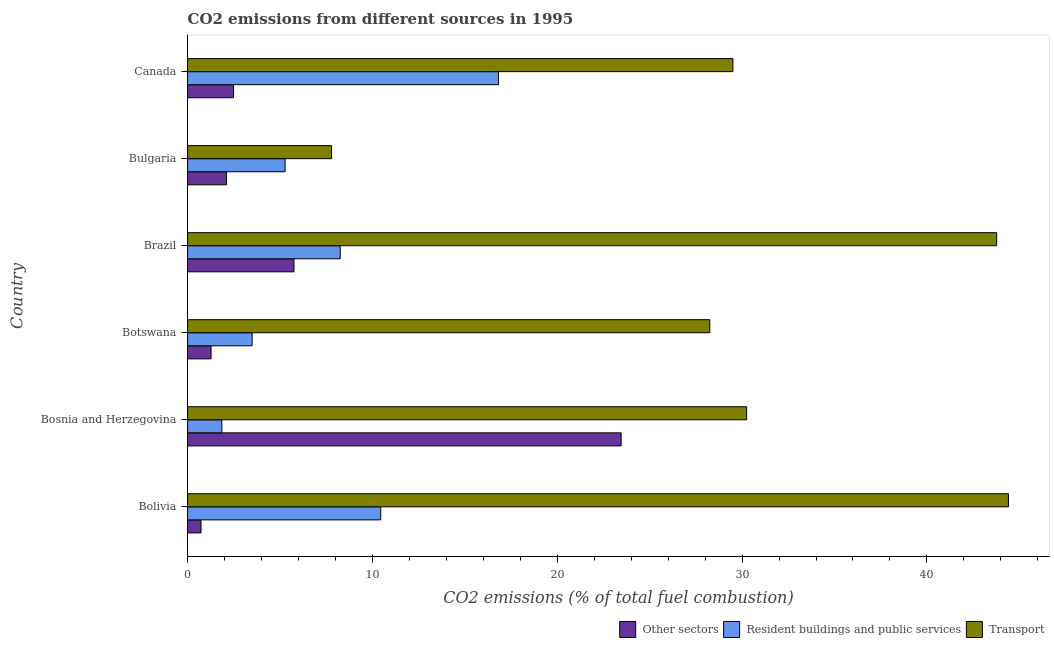How many different coloured bars are there?
Ensure brevity in your answer.  3. Are the number of bars per tick equal to the number of legend labels?
Offer a terse response. Yes. Are the number of bars on each tick of the Y-axis equal?
Make the answer very short. Yes. How many bars are there on the 6th tick from the bottom?
Offer a terse response. 3. What is the label of the 5th group of bars from the top?
Provide a succinct answer. Bosnia and Herzegovina. What is the percentage of co2 emissions from other sectors in Bosnia and Herzegovina?
Provide a short and direct response. 23.46. Across all countries, what is the maximum percentage of co2 emissions from transport?
Your answer should be very brief. 44.41. Across all countries, what is the minimum percentage of co2 emissions from other sectors?
Your response must be concise. 0.73. In which country was the percentage of co2 emissions from other sectors minimum?
Provide a succinct answer. Bolivia. What is the total percentage of co2 emissions from resident buildings and public services in the graph?
Provide a short and direct response. 46.15. What is the difference between the percentage of co2 emissions from transport in Botswana and that in Brazil?
Offer a terse response. -15.52. What is the difference between the percentage of co2 emissions from transport in Brazil and the percentage of co2 emissions from resident buildings and public services in Canada?
Give a very brief answer. 26.95. What is the average percentage of co2 emissions from other sectors per country?
Provide a succinct answer. 5.97. What is the difference between the percentage of co2 emissions from resident buildings and public services and percentage of co2 emissions from transport in Canada?
Your response must be concise. -12.68. What is the ratio of the percentage of co2 emissions from other sectors in Bosnia and Herzegovina to that in Botswana?
Offer a terse response. 18.47. What is the difference between the highest and the second highest percentage of co2 emissions from resident buildings and public services?
Offer a terse response. 6.37. What is the difference between the highest and the lowest percentage of co2 emissions from transport?
Provide a succinct answer. 36.62. Is the sum of the percentage of co2 emissions from resident buildings and public services in Bolivia and Brazil greater than the maximum percentage of co2 emissions from other sectors across all countries?
Provide a short and direct response. No. What does the 1st bar from the top in Botswana represents?
Offer a very short reply. Transport. What does the 1st bar from the bottom in Bolivia represents?
Provide a short and direct response. Other sectors. How many bars are there?
Make the answer very short. 18. Are all the bars in the graph horizontal?
Offer a terse response. Yes. Are the values on the major ticks of X-axis written in scientific E-notation?
Keep it short and to the point. No. Does the graph contain any zero values?
Provide a short and direct response. No. Does the graph contain grids?
Give a very brief answer. No. What is the title of the graph?
Your response must be concise. CO2 emissions from different sources in 1995. What is the label or title of the X-axis?
Your response must be concise. CO2 emissions (% of total fuel combustion). What is the CO2 emissions (% of total fuel combustion) in Other sectors in Bolivia?
Offer a very short reply. 0.73. What is the CO2 emissions (% of total fuel combustion) in Resident buildings and public services in Bolivia?
Offer a terse response. 10.45. What is the CO2 emissions (% of total fuel combustion) of Transport in Bolivia?
Provide a short and direct response. 44.41. What is the CO2 emissions (% of total fuel combustion) of Other sectors in Bosnia and Herzegovina?
Your response must be concise. 23.46. What is the CO2 emissions (% of total fuel combustion) of Resident buildings and public services in Bosnia and Herzegovina?
Your answer should be very brief. 1.85. What is the CO2 emissions (% of total fuel combustion) in Transport in Bosnia and Herzegovina?
Ensure brevity in your answer.  30.25. What is the CO2 emissions (% of total fuel combustion) of Other sectors in Botswana?
Give a very brief answer. 1.27. What is the CO2 emissions (% of total fuel combustion) of Resident buildings and public services in Botswana?
Your answer should be very brief. 3.49. What is the CO2 emissions (% of total fuel combustion) in Transport in Botswana?
Keep it short and to the point. 28.25. What is the CO2 emissions (% of total fuel combustion) in Other sectors in Brazil?
Keep it short and to the point. 5.76. What is the CO2 emissions (% of total fuel combustion) in Resident buildings and public services in Brazil?
Your response must be concise. 8.26. What is the CO2 emissions (% of total fuel combustion) in Transport in Brazil?
Give a very brief answer. 43.77. What is the CO2 emissions (% of total fuel combustion) of Other sectors in Bulgaria?
Provide a short and direct response. 2.1. What is the CO2 emissions (% of total fuel combustion) in Resident buildings and public services in Bulgaria?
Provide a succinct answer. 5.28. What is the CO2 emissions (% of total fuel combustion) in Transport in Bulgaria?
Your answer should be very brief. 7.79. What is the CO2 emissions (% of total fuel combustion) in Other sectors in Canada?
Your answer should be compact. 2.49. What is the CO2 emissions (% of total fuel combustion) of Resident buildings and public services in Canada?
Your answer should be very brief. 16.82. What is the CO2 emissions (% of total fuel combustion) of Transport in Canada?
Offer a very short reply. 29.5. Across all countries, what is the maximum CO2 emissions (% of total fuel combustion) in Other sectors?
Give a very brief answer. 23.46. Across all countries, what is the maximum CO2 emissions (% of total fuel combustion) in Resident buildings and public services?
Keep it short and to the point. 16.82. Across all countries, what is the maximum CO2 emissions (% of total fuel combustion) in Transport?
Offer a very short reply. 44.41. Across all countries, what is the minimum CO2 emissions (% of total fuel combustion) of Other sectors?
Your response must be concise. 0.73. Across all countries, what is the minimum CO2 emissions (% of total fuel combustion) in Resident buildings and public services?
Provide a succinct answer. 1.85. Across all countries, what is the minimum CO2 emissions (% of total fuel combustion) of Transport?
Provide a succinct answer. 7.79. What is the total CO2 emissions (% of total fuel combustion) of Other sectors in the graph?
Your answer should be very brief. 35.8. What is the total CO2 emissions (% of total fuel combustion) in Resident buildings and public services in the graph?
Provide a short and direct response. 46.15. What is the total CO2 emissions (% of total fuel combustion) of Transport in the graph?
Make the answer very short. 183.98. What is the difference between the CO2 emissions (% of total fuel combustion) of Other sectors in Bolivia and that in Bosnia and Herzegovina?
Your response must be concise. -22.73. What is the difference between the CO2 emissions (% of total fuel combustion) in Resident buildings and public services in Bolivia and that in Bosnia and Herzegovina?
Your response must be concise. 8.6. What is the difference between the CO2 emissions (% of total fuel combustion) of Transport in Bolivia and that in Bosnia and Herzegovina?
Offer a very short reply. 14.17. What is the difference between the CO2 emissions (% of total fuel combustion) in Other sectors in Bolivia and that in Botswana?
Give a very brief answer. -0.54. What is the difference between the CO2 emissions (% of total fuel combustion) in Resident buildings and public services in Bolivia and that in Botswana?
Ensure brevity in your answer.  6.96. What is the difference between the CO2 emissions (% of total fuel combustion) in Transport in Bolivia and that in Botswana?
Provide a short and direct response. 16.16. What is the difference between the CO2 emissions (% of total fuel combustion) in Other sectors in Bolivia and that in Brazil?
Your response must be concise. -5.03. What is the difference between the CO2 emissions (% of total fuel combustion) of Resident buildings and public services in Bolivia and that in Brazil?
Offer a very short reply. 2.19. What is the difference between the CO2 emissions (% of total fuel combustion) in Transport in Bolivia and that in Brazil?
Provide a short and direct response. 0.64. What is the difference between the CO2 emissions (% of total fuel combustion) of Other sectors in Bolivia and that in Bulgaria?
Your answer should be compact. -1.38. What is the difference between the CO2 emissions (% of total fuel combustion) in Resident buildings and public services in Bolivia and that in Bulgaria?
Your answer should be compact. 5.17. What is the difference between the CO2 emissions (% of total fuel combustion) in Transport in Bolivia and that in Bulgaria?
Your response must be concise. 36.62. What is the difference between the CO2 emissions (% of total fuel combustion) in Other sectors in Bolivia and that in Canada?
Your response must be concise. -1.76. What is the difference between the CO2 emissions (% of total fuel combustion) in Resident buildings and public services in Bolivia and that in Canada?
Ensure brevity in your answer.  -6.37. What is the difference between the CO2 emissions (% of total fuel combustion) in Transport in Bolivia and that in Canada?
Your answer should be compact. 14.91. What is the difference between the CO2 emissions (% of total fuel combustion) in Other sectors in Bosnia and Herzegovina and that in Botswana?
Your answer should be very brief. 22.19. What is the difference between the CO2 emissions (% of total fuel combustion) in Resident buildings and public services in Bosnia and Herzegovina and that in Botswana?
Make the answer very short. -1.64. What is the difference between the CO2 emissions (% of total fuel combustion) of Transport in Bosnia and Herzegovina and that in Botswana?
Your answer should be very brief. 1.99. What is the difference between the CO2 emissions (% of total fuel combustion) in Other sectors in Bosnia and Herzegovina and that in Brazil?
Offer a terse response. 17.7. What is the difference between the CO2 emissions (% of total fuel combustion) of Resident buildings and public services in Bosnia and Herzegovina and that in Brazil?
Offer a terse response. -6.4. What is the difference between the CO2 emissions (% of total fuel combustion) in Transport in Bosnia and Herzegovina and that in Brazil?
Ensure brevity in your answer.  -13.53. What is the difference between the CO2 emissions (% of total fuel combustion) of Other sectors in Bosnia and Herzegovina and that in Bulgaria?
Your answer should be compact. 21.35. What is the difference between the CO2 emissions (% of total fuel combustion) of Resident buildings and public services in Bosnia and Herzegovina and that in Bulgaria?
Provide a short and direct response. -3.42. What is the difference between the CO2 emissions (% of total fuel combustion) in Transport in Bosnia and Herzegovina and that in Bulgaria?
Ensure brevity in your answer.  22.46. What is the difference between the CO2 emissions (% of total fuel combustion) of Other sectors in Bosnia and Herzegovina and that in Canada?
Provide a short and direct response. 20.97. What is the difference between the CO2 emissions (% of total fuel combustion) in Resident buildings and public services in Bosnia and Herzegovina and that in Canada?
Make the answer very short. -14.97. What is the difference between the CO2 emissions (% of total fuel combustion) in Transport in Bosnia and Herzegovina and that in Canada?
Make the answer very short. 0.74. What is the difference between the CO2 emissions (% of total fuel combustion) of Other sectors in Botswana and that in Brazil?
Keep it short and to the point. -4.49. What is the difference between the CO2 emissions (% of total fuel combustion) of Resident buildings and public services in Botswana and that in Brazil?
Offer a terse response. -4.76. What is the difference between the CO2 emissions (% of total fuel combustion) in Transport in Botswana and that in Brazil?
Offer a very short reply. -15.52. What is the difference between the CO2 emissions (% of total fuel combustion) in Other sectors in Botswana and that in Bulgaria?
Your answer should be very brief. -0.83. What is the difference between the CO2 emissions (% of total fuel combustion) in Resident buildings and public services in Botswana and that in Bulgaria?
Provide a succinct answer. -1.78. What is the difference between the CO2 emissions (% of total fuel combustion) in Transport in Botswana and that in Bulgaria?
Provide a succinct answer. 20.46. What is the difference between the CO2 emissions (% of total fuel combustion) in Other sectors in Botswana and that in Canada?
Give a very brief answer. -1.22. What is the difference between the CO2 emissions (% of total fuel combustion) of Resident buildings and public services in Botswana and that in Canada?
Provide a short and direct response. -13.33. What is the difference between the CO2 emissions (% of total fuel combustion) of Transport in Botswana and that in Canada?
Your answer should be compact. -1.25. What is the difference between the CO2 emissions (% of total fuel combustion) of Other sectors in Brazil and that in Bulgaria?
Provide a short and direct response. 3.65. What is the difference between the CO2 emissions (% of total fuel combustion) of Resident buildings and public services in Brazil and that in Bulgaria?
Provide a short and direct response. 2.98. What is the difference between the CO2 emissions (% of total fuel combustion) of Transport in Brazil and that in Bulgaria?
Ensure brevity in your answer.  35.98. What is the difference between the CO2 emissions (% of total fuel combustion) of Other sectors in Brazil and that in Canada?
Your answer should be compact. 3.27. What is the difference between the CO2 emissions (% of total fuel combustion) of Resident buildings and public services in Brazil and that in Canada?
Provide a succinct answer. -8.57. What is the difference between the CO2 emissions (% of total fuel combustion) of Transport in Brazil and that in Canada?
Your answer should be very brief. 14.27. What is the difference between the CO2 emissions (% of total fuel combustion) of Other sectors in Bulgaria and that in Canada?
Keep it short and to the point. -0.38. What is the difference between the CO2 emissions (% of total fuel combustion) in Resident buildings and public services in Bulgaria and that in Canada?
Offer a terse response. -11.55. What is the difference between the CO2 emissions (% of total fuel combustion) of Transport in Bulgaria and that in Canada?
Your answer should be very brief. -21.71. What is the difference between the CO2 emissions (% of total fuel combustion) of Other sectors in Bolivia and the CO2 emissions (% of total fuel combustion) of Resident buildings and public services in Bosnia and Herzegovina?
Ensure brevity in your answer.  -1.13. What is the difference between the CO2 emissions (% of total fuel combustion) in Other sectors in Bolivia and the CO2 emissions (% of total fuel combustion) in Transport in Bosnia and Herzegovina?
Provide a succinct answer. -29.52. What is the difference between the CO2 emissions (% of total fuel combustion) of Resident buildings and public services in Bolivia and the CO2 emissions (% of total fuel combustion) of Transport in Bosnia and Herzegovina?
Offer a very short reply. -19.8. What is the difference between the CO2 emissions (% of total fuel combustion) in Other sectors in Bolivia and the CO2 emissions (% of total fuel combustion) in Resident buildings and public services in Botswana?
Offer a terse response. -2.77. What is the difference between the CO2 emissions (% of total fuel combustion) of Other sectors in Bolivia and the CO2 emissions (% of total fuel combustion) of Transport in Botswana?
Give a very brief answer. -27.53. What is the difference between the CO2 emissions (% of total fuel combustion) in Resident buildings and public services in Bolivia and the CO2 emissions (% of total fuel combustion) in Transport in Botswana?
Offer a very short reply. -17.8. What is the difference between the CO2 emissions (% of total fuel combustion) in Other sectors in Bolivia and the CO2 emissions (% of total fuel combustion) in Resident buildings and public services in Brazil?
Ensure brevity in your answer.  -7.53. What is the difference between the CO2 emissions (% of total fuel combustion) of Other sectors in Bolivia and the CO2 emissions (% of total fuel combustion) of Transport in Brazil?
Provide a succinct answer. -43.05. What is the difference between the CO2 emissions (% of total fuel combustion) in Resident buildings and public services in Bolivia and the CO2 emissions (% of total fuel combustion) in Transport in Brazil?
Offer a very short reply. -33.32. What is the difference between the CO2 emissions (% of total fuel combustion) of Other sectors in Bolivia and the CO2 emissions (% of total fuel combustion) of Resident buildings and public services in Bulgaria?
Offer a terse response. -4.55. What is the difference between the CO2 emissions (% of total fuel combustion) of Other sectors in Bolivia and the CO2 emissions (% of total fuel combustion) of Transport in Bulgaria?
Provide a short and direct response. -7.06. What is the difference between the CO2 emissions (% of total fuel combustion) of Resident buildings and public services in Bolivia and the CO2 emissions (% of total fuel combustion) of Transport in Bulgaria?
Provide a short and direct response. 2.66. What is the difference between the CO2 emissions (% of total fuel combustion) in Other sectors in Bolivia and the CO2 emissions (% of total fuel combustion) in Resident buildings and public services in Canada?
Offer a terse response. -16.1. What is the difference between the CO2 emissions (% of total fuel combustion) of Other sectors in Bolivia and the CO2 emissions (% of total fuel combustion) of Transport in Canada?
Provide a succinct answer. -28.78. What is the difference between the CO2 emissions (% of total fuel combustion) of Resident buildings and public services in Bolivia and the CO2 emissions (% of total fuel combustion) of Transport in Canada?
Keep it short and to the point. -19.05. What is the difference between the CO2 emissions (% of total fuel combustion) in Other sectors in Bosnia and Herzegovina and the CO2 emissions (% of total fuel combustion) in Resident buildings and public services in Botswana?
Your answer should be compact. 19.96. What is the difference between the CO2 emissions (% of total fuel combustion) in Other sectors in Bosnia and Herzegovina and the CO2 emissions (% of total fuel combustion) in Transport in Botswana?
Provide a succinct answer. -4.8. What is the difference between the CO2 emissions (% of total fuel combustion) of Resident buildings and public services in Bosnia and Herzegovina and the CO2 emissions (% of total fuel combustion) of Transport in Botswana?
Offer a very short reply. -26.4. What is the difference between the CO2 emissions (% of total fuel combustion) of Other sectors in Bosnia and Herzegovina and the CO2 emissions (% of total fuel combustion) of Resident buildings and public services in Brazil?
Offer a terse response. 15.2. What is the difference between the CO2 emissions (% of total fuel combustion) in Other sectors in Bosnia and Herzegovina and the CO2 emissions (% of total fuel combustion) in Transport in Brazil?
Keep it short and to the point. -20.32. What is the difference between the CO2 emissions (% of total fuel combustion) of Resident buildings and public services in Bosnia and Herzegovina and the CO2 emissions (% of total fuel combustion) of Transport in Brazil?
Your response must be concise. -41.92. What is the difference between the CO2 emissions (% of total fuel combustion) in Other sectors in Bosnia and Herzegovina and the CO2 emissions (% of total fuel combustion) in Resident buildings and public services in Bulgaria?
Ensure brevity in your answer.  18.18. What is the difference between the CO2 emissions (% of total fuel combustion) of Other sectors in Bosnia and Herzegovina and the CO2 emissions (% of total fuel combustion) of Transport in Bulgaria?
Ensure brevity in your answer.  15.67. What is the difference between the CO2 emissions (% of total fuel combustion) of Resident buildings and public services in Bosnia and Herzegovina and the CO2 emissions (% of total fuel combustion) of Transport in Bulgaria?
Ensure brevity in your answer.  -5.94. What is the difference between the CO2 emissions (% of total fuel combustion) of Other sectors in Bosnia and Herzegovina and the CO2 emissions (% of total fuel combustion) of Resident buildings and public services in Canada?
Your response must be concise. 6.63. What is the difference between the CO2 emissions (% of total fuel combustion) of Other sectors in Bosnia and Herzegovina and the CO2 emissions (% of total fuel combustion) of Transport in Canada?
Give a very brief answer. -6.05. What is the difference between the CO2 emissions (% of total fuel combustion) of Resident buildings and public services in Bosnia and Herzegovina and the CO2 emissions (% of total fuel combustion) of Transport in Canada?
Offer a terse response. -27.65. What is the difference between the CO2 emissions (% of total fuel combustion) in Other sectors in Botswana and the CO2 emissions (% of total fuel combustion) in Resident buildings and public services in Brazil?
Provide a succinct answer. -6.99. What is the difference between the CO2 emissions (% of total fuel combustion) in Other sectors in Botswana and the CO2 emissions (% of total fuel combustion) in Transport in Brazil?
Provide a succinct answer. -42.5. What is the difference between the CO2 emissions (% of total fuel combustion) in Resident buildings and public services in Botswana and the CO2 emissions (% of total fuel combustion) in Transport in Brazil?
Give a very brief answer. -40.28. What is the difference between the CO2 emissions (% of total fuel combustion) in Other sectors in Botswana and the CO2 emissions (% of total fuel combustion) in Resident buildings and public services in Bulgaria?
Keep it short and to the point. -4.01. What is the difference between the CO2 emissions (% of total fuel combustion) in Other sectors in Botswana and the CO2 emissions (% of total fuel combustion) in Transport in Bulgaria?
Make the answer very short. -6.52. What is the difference between the CO2 emissions (% of total fuel combustion) in Resident buildings and public services in Botswana and the CO2 emissions (% of total fuel combustion) in Transport in Bulgaria?
Ensure brevity in your answer.  -4.3. What is the difference between the CO2 emissions (% of total fuel combustion) in Other sectors in Botswana and the CO2 emissions (% of total fuel combustion) in Resident buildings and public services in Canada?
Offer a terse response. -15.55. What is the difference between the CO2 emissions (% of total fuel combustion) in Other sectors in Botswana and the CO2 emissions (% of total fuel combustion) in Transport in Canada?
Provide a succinct answer. -28.23. What is the difference between the CO2 emissions (% of total fuel combustion) of Resident buildings and public services in Botswana and the CO2 emissions (% of total fuel combustion) of Transport in Canada?
Your answer should be compact. -26.01. What is the difference between the CO2 emissions (% of total fuel combustion) in Other sectors in Brazil and the CO2 emissions (% of total fuel combustion) in Resident buildings and public services in Bulgaria?
Your answer should be very brief. 0.48. What is the difference between the CO2 emissions (% of total fuel combustion) in Other sectors in Brazil and the CO2 emissions (% of total fuel combustion) in Transport in Bulgaria?
Ensure brevity in your answer.  -2.03. What is the difference between the CO2 emissions (% of total fuel combustion) of Resident buildings and public services in Brazil and the CO2 emissions (% of total fuel combustion) of Transport in Bulgaria?
Your answer should be compact. 0.47. What is the difference between the CO2 emissions (% of total fuel combustion) of Other sectors in Brazil and the CO2 emissions (% of total fuel combustion) of Resident buildings and public services in Canada?
Make the answer very short. -11.07. What is the difference between the CO2 emissions (% of total fuel combustion) in Other sectors in Brazil and the CO2 emissions (% of total fuel combustion) in Transport in Canada?
Your response must be concise. -23.75. What is the difference between the CO2 emissions (% of total fuel combustion) of Resident buildings and public services in Brazil and the CO2 emissions (% of total fuel combustion) of Transport in Canada?
Provide a short and direct response. -21.25. What is the difference between the CO2 emissions (% of total fuel combustion) of Other sectors in Bulgaria and the CO2 emissions (% of total fuel combustion) of Resident buildings and public services in Canada?
Your response must be concise. -14.72. What is the difference between the CO2 emissions (% of total fuel combustion) of Other sectors in Bulgaria and the CO2 emissions (% of total fuel combustion) of Transport in Canada?
Ensure brevity in your answer.  -27.4. What is the difference between the CO2 emissions (% of total fuel combustion) of Resident buildings and public services in Bulgaria and the CO2 emissions (% of total fuel combustion) of Transport in Canada?
Offer a very short reply. -24.23. What is the average CO2 emissions (% of total fuel combustion) in Other sectors per country?
Give a very brief answer. 5.97. What is the average CO2 emissions (% of total fuel combustion) in Resident buildings and public services per country?
Offer a very short reply. 7.69. What is the average CO2 emissions (% of total fuel combustion) in Transport per country?
Offer a very short reply. 30.66. What is the difference between the CO2 emissions (% of total fuel combustion) in Other sectors and CO2 emissions (% of total fuel combustion) in Resident buildings and public services in Bolivia?
Ensure brevity in your answer.  -9.72. What is the difference between the CO2 emissions (% of total fuel combustion) in Other sectors and CO2 emissions (% of total fuel combustion) in Transport in Bolivia?
Offer a very short reply. -43.69. What is the difference between the CO2 emissions (% of total fuel combustion) of Resident buildings and public services and CO2 emissions (% of total fuel combustion) of Transport in Bolivia?
Your answer should be very brief. -33.96. What is the difference between the CO2 emissions (% of total fuel combustion) of Other sectors and CO2 emissions (% of total fuel combustion) of Resident buildings and public services in Bosnia and Herzegovina?
Make the answer very short. 21.6. What is the difference between the CO2 emissions (% of total fuel combustion) of Other sectors and CO2 emissions (% of total fuel combustion) of Transport in Bosnia and Herzegovina?
Offer a very short reply. -6.79. What is the difference between the CO2 emissions (% of total fuel combustion) in Resident buildings and public services and CO2 emissions (% of total fuel combustion) in Transport in Bosnia and Herzegovina?
Your answer should be compact. -28.4. What is the difference between the CO2 emissions (% of total fuel combustion) of Other sectors and CO2 emissions (% of total fuel combustion) of Resident buildings and public services in Botswana?
Give a very brief answer. -2.22. What is the difference between the CO2 emissions (% of total fuel combustion) in Other sectors and CO2 emissions (% of total fuel combustion) in Transport in Botswana?
Your answer should be very brief. -26.98. What is the difference between the CO2 emissions (% of total fuel combustion) of Resident buildings and public services and CO2 emissions (% of total fuel combustion) of Transport in Botswana?
Give a very brief answer. -24.76. What is the difference between the CO2 emissions (% of total fuel combustion) of Other sectors and CO2 emissions (% of total fuel combustion) of Resident buildings and public services in Brazil?
Give a very brief answer. -2.5. What is the difference between the CO2 emissions (% of total fuel combustion) in Other sectors and CO2 emissions (% of total fuel combustion) in Transport in Brazil?
Ensure brevity in your answer.  -38.02. What is the difference between the CO2 emissions (% of total fuel combustion) of Resident buildings and public services and CO2 emissions (% of total fuel combustion) of Transport in Brazil?
Give a very brief answer. -35.52. What is the difference between the CO2 emissions (% of total fuel combustion) in Other sectors and CO2 emissions (% of total fuel combustion) in Resident buildings and public services in Bulgaria?
Your response must be concise. -3.17. What is the difference between the CO2 emissions (% of total fuel combustion) of Other sectors and CO2 emissions (% of total fuel combustion) of Transport in Bulgaria?
Make the answer very short. -5.69. What is the difference between the CO2 emissions (% of total fuel combustion) of Resident buildings and public services and CO2 emissions (% of total fuel combustion) of Transport in Bulgaria?
Provide a short and direct response. -2.52. What is the difference between the CO2 emissions (% of total fuel combustion) of Other sectors and CO2 emissions (% of total fuel combustion) of Resident buildings and public services in Canada?
Your answer should be compact. -14.34. What is the difference between the CO2 emissions (% of total fuel combustion) in Other sectors and CO2 emissions (% of total fuel combustion) in Transport in Canada?
Offer a terse response. -27.02. What is the difference between the CO2 emissions (% of total fuel combustion) of Resident buildings and public services and CO2 emissions (% of total fuel combustion) of Transport in Canada?
Provide a short and direct response. -12.68. What is the ratio of the CO2 emissions (% of total fuel combustion) in Other sectors in Bolivia to that in Bosnia and Herzegovina?
Ensure brevity in your answer.  0.03. What is the ratio of the CO2 emissions (% of total fuel combustion) in Resident buildings and public services in Bolivia to that in Bosnia and Herzegovina?
Your answer should be very brief. 5.64. What is the ratio of the CO2 emissions (% of total fuel combustion) of Transport in Bolivia to that in Bosnia and Herzegovina?
Ensure brevity in your answer.  1.47. What is the ratio of the CO2 emissions (% of total fuel combustion) of Other sectors in Bolivia to that in Botswana?
Keep it short and to the point. 0.57. What is the ratio of the CO2 emissions (% of total fuel combustion) of Resident buildings and public services in Bolivia to that in Botswana?
Your answer should be very brief. 2.99. What is the ratio of the CO2 emissions (% of total fuel combustion) of Transport in Bolivia to that in Botswana?
Your answer should be compact. 1.57. What is the ratio of the CO2 emissions (% of total fuel combustion) in Other sectors in Bolivia to that in Brazil?
Your response must be concise. 0.13. What is the ratio of the CO2 emissions (% of total fuel combustion) in Resident buildings and public services in Bolivia to that in Brazil?
Give a very brief answer. 1.27. What is the ratio of the CO2 emissions (% of total fuel combustion) of Transport in Bolivia to that in Brazil?
Make the answer very short. 1.01. What is the ratio of the CO2 emissions (% of total fuel combustion) in Other sectors in Bolivia to that in Bulgaria?
Provide a succinct answer. 0.35. What is the ratio of the CO2 emissions (% of total fuel combustion) in Resident buildings and public services in Bolivia to that in Bulgaria?
Ensure brevity in your answer.  1.98. What is the ratio of the CO2 emissions (% of total fuel combustion) in Transport in Bolivia to that in Bulgaria?
Keep it short and to the point. 5.7. What is the ratio of the CO2 emissions (% of total fuel combustion) of Other sectors in Bolivia to that in Canada?
Keep it short and to the point. 0.29. What is the ratio of the CO2 emissions (% of total fuel combustion) of Resident buildings and public services in Bolivia to that in Canada?
Your answer should be compact. 0.62. What is the ratio of the CO2 emissions (% of total fuel combustion) of Transport in Bolivia to that in Canada?
Give a very brief answer. 1.51. What is the ratio of the CO2 emissions (% of total fuel combustion) in Other sectors in Bosnia and Herzegovina to that in Botswana?
Provide a succinct answer. 18.47. What is the ratio of the CO2 emissions (% of total fuel combustion) in Resident buildings and public services in Bosnia and Herzegovina to that in Botswana?
Make the answer very short. 0.53. What is the ratio of the CO2 emissions (% of total fuel combustion) of Transport in Bosnia and Herzegovina to that in Botswana?
Your response must be concise. 1.07. What is the ratio of the CO2 emissions (% of total fuel combustion) of Other sectors in Bosnia and Herzegovina to that in Brazil?
Provide a short and direct response. 4.08. What is the ratio of the CO2 emissions (% of total fuel combustion) in Resident buildings and public services in Bosnia and Herzegovina to that in Brazil?
Give a very brief answer. 0.22. What is the ratio of the CO2 emissions (% of total fuel combustion) in Transport in Bosnia and Herzegovina to that in Brazil?
Provide a short and direct response. 0.69. What is the ratio of the CO2 emissions (% of total fuel combustion) in Other sectors in Bosnia and Herzegovina to that in Bulgaria?
Your answer should be very brief. 11.16. What is the ratio of the CO2 emissions (% of total fuel combustion) in Resident buildings and public services in Bosnia and Herzegovina to that in Bulgaria?
Provide a short and direct response. 0.35. What is the ratio of the CO2 emissions (% of total fuel combustion) in Transport in Bosnia and Herzegovina to that in Bulgaria?
Provide a succinct answer. 3.88. What is the ratio of the CO2 emissions (% of total fuel combustion) in Other sectors in Bosnia and Herzegovina to that in Canada?
Your response must be concise. 9.43. What is the ratio of the CO2 emissions (% of total fuel combustion) in Resident buildings and public services in Bosnia and Herzegovina to that in Canada?
Give a very brief answer. 0.11. What is the ratio of the CO2 emissions (% of total fuel combustion) in Transport in Bosnia and Herzegovina to that in Canada?
Provide a succinct answer. 1.03. What is the ratio of the CO2 emissions (% of total fuel combustion) of Other sectors in Botswana to that in Brazil?
Offer a very short reply. 0.22. What is the ratio of the CO2 emissions (% of total fuel combustion) in Resident buildings and public services in Botswana to that in Brazil?
Give a very brief answer. 0.42. What is the ratio of the CO2 emissions (% of total fuel combustion) in Transport in Botswana to that in Brazil?
Provide a succinct answer. 0.65. What is the ratio of the CO2 emissions (% of total fuel combustion) of Other sectors in Botswana to that in Bulgaria?
Make the answer very short. 0.6. What is the ratio of the CO2 emissions (% of total fuel combustion) of Resident buildings and public services in Botswana to that in Bulgaria?
Provide a short and direct response. 0.66. What is the ratio of the CO2 emissions (% of total fuel combustion) in Transport in Botswana to that in Bulgaria?
Provide a short and direct response. 3.63. What is the ratio of the CO2 emissions (% of total fuel combustion) in Other sectors in Botswana to that in Canada?
Provide a short and direct response. 0.51. What is the ratio of the CO2 emissions (% of total fuel combustion) of Resident buildings and public services in Botswana to that in Canada?
Make the answer very short. 0.21. What is the ratio of the CO2 emissions (% of total fuel combustion) in Transport in Botswana to that in Canada?
Your answer should be compact. 0.96. What is the ratio of the CO2 emissions (% of total fuel combustion) in Other sectors in Brazil to that in Bulgaria?
Give a very brief answer. 2.74. What is the ratio of the CO2 emissions (% of total fuel combustion) in Resident buildings and public services in Brazil to that in Bulgaria?
Make the answer very short. 1.57. What is the ratio of the CO2 emissions (% of total fuel combustion) in Transport in Brazil to that in Bulgaria?
Your answer should be very brief. 5.62. What is the ratio of the CO2 emissions (% of total fuel combustion) of Other sectors in Brazil to that in Canada?
Offer a very short reply. 2.31. What is the ratio of the CO2 emissions (% of total fuel combustion) of Resident buildings and public services in Brazil to that in Canada?
Your answer should be compact. 0.49. What is the ratio of the CO2 emissions (% of total fuel combustion) of Transport in Brazil to that in Canada?
Keep it short and to the point. 1.48. What is the ratio of the CO2 emissions (% of total fuel combustion) of Other sectors in Bulgaria to that in Canada?
Keep it short and to the point. 0.85. What is the ratio of the CO2 emissions (% of total fuel combustion) of Resident buildings and public services in Bulgaria to that in Canada?
Keep it short and to the point. 0.31. What is the ratio of the CO2 emissions (% of total fuel combustion) of Transport in Bulgaria to that in Canada?
Provide a succinct answer. 0.26. What is the difference between the highest and the second highest CO2 emissions (% of total fuel combustion) of Other sectors?
Offer a very short reply. 17.7. What is the difference between the highest and the second highest CO2 emissions (% of total fuel combustion) in Resident buildings and public services?
Your response must be concise. 6.37. What is the difference between the highest and the second highest CO2 emissions (% of total fuel combustion) in Transport?
Your response must be concise. 0.64. What is the difference between the highest and the lowest CO2 emissions (% of total fuel combustion) of Other sectors?
Make the answer very short. 22.73. What is the difference between the highest and the lowest CO2 emissions (% of total fuel combustion) in Resident buildings and public services?
Offer a very short reply. 14.97. What is the difference between the highest and the lowest CO2 emissions (% of total fuel combustion) of Transport?
Ensure brevity in your answer.  36.62. 